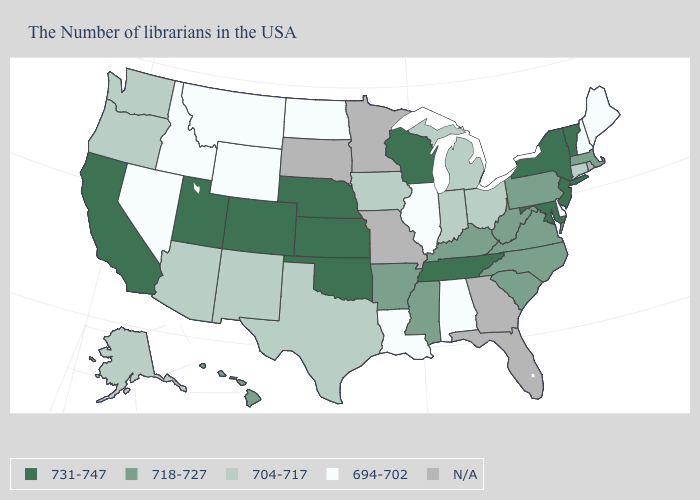How many symbols are there in the legend?
Quick response, please. 5. Name the states that have a value in the range 731-747?
Keep it brief. Vermont, New York, New Jersey, Maryland, Tennessee, Wisconsin, Kansas, Nebraska, Oklahoma, Colorado, Utah, California. What is the value of Illinois?
Quick response, please. 694-702. What is the value of Nebraska?
Be succinct. 731-747. Does the map have missing data?
Short answer required. Yes. Among the states that border New Hampshire , which have the lowest value?
Give a very brief answer. Maine. What is the highest value in the USA?
Answer briefly. 731-747. What is the value of Illinois?
Keep it brief. 694-702. Which states have the lowest value in the USA?
Write a very short answer. Maine, New Hampshire, Delaware, Alabama, Illinois, Louisiana, North Dakota, Wyoming, Montana, Idaho, Nevada. What is the value of Tennessee?
Keep it brief. 731-747. What is the highest value in the USA?
Quick response, please. 731-747. Name the states that have a value in the range 704-717?
Concise answer only. Connecticut, Ohio, Michigan, Indiana, Iowa, Texas, New Mexico, Arizona, Washington, Oregon, Alaska. What is the value of Missouri?
Be succinct. N/A. Does the map have missing data?
Quick response, please. Yes. Among the states that border Delaware , which have the highest value?
Be succinct. New Jersey, Maryland. 